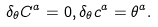<formula> <loc_0><loc_0><loc_500><loc_500>\delta _ { \theta } C ^ { a } = 0 , \delta _ { \theta } c ^ { a } = \theta ^ { a } .</formula> 